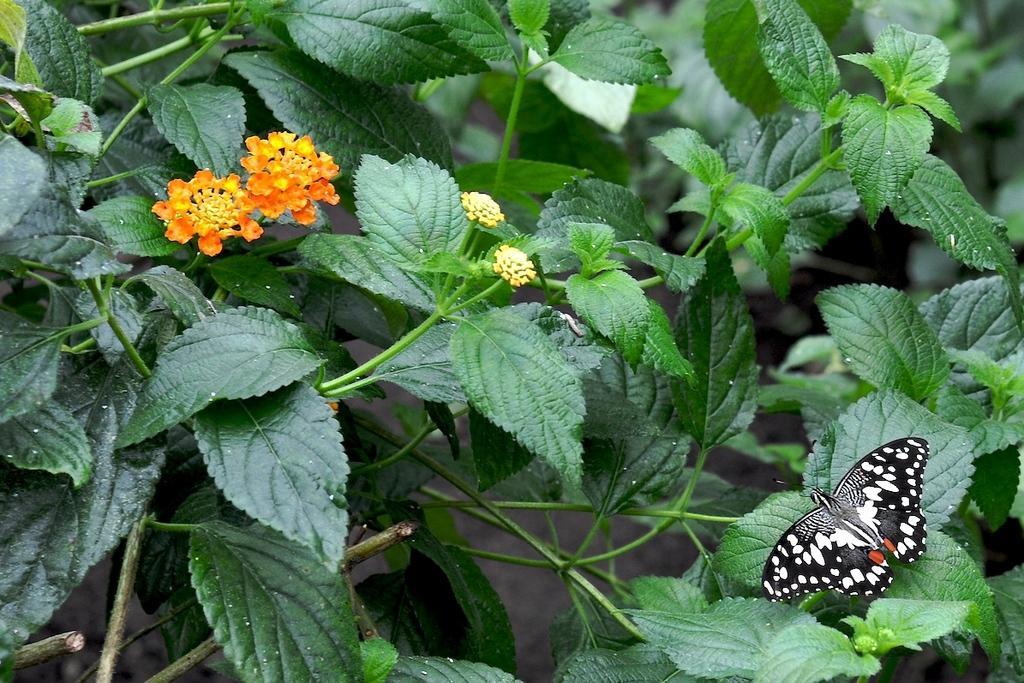Describe this image in one or two sentences. In this image I can see a butterfly on flower plants. 